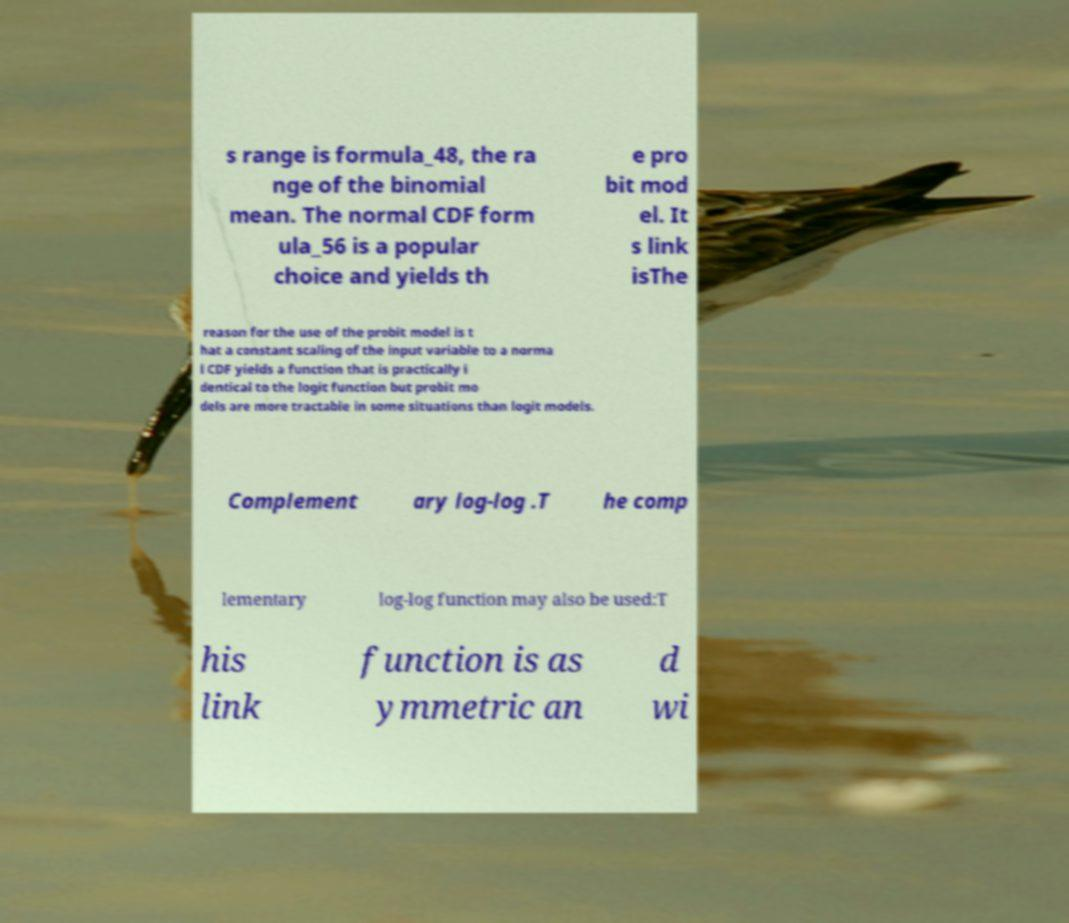Please read and relay the text visible in this image. What does it say? s range is formula_48, the ra nge of the binomial mean. The normal CDF form ula_56 is a popular choice and yields th e pro bit mod el. It s link isThe reason for the use of the probit model is t hat a constant scaling of the input variable to a norma l CDF yields a function that is practically i dentical to the logit function but probit mo dels are more tractable in some situations than logit models. Complement ary log-log .T he comp lementary log-log function may also be used:T his link function is as ymmetric an d wi 